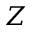<formula> <loc_0><loc_0><loc_500><loc_500>Z</formula> 